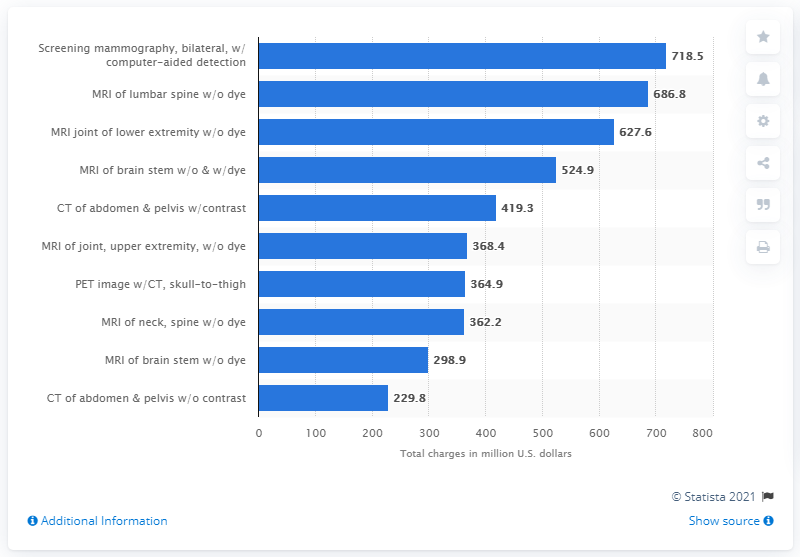List a handful of essential elements in this visual. The total charges for an MRI of the neck without dye in 2018 were approximately $364.9. The total charges for an MRI of the neck without dye in 2018 were 364.9. 